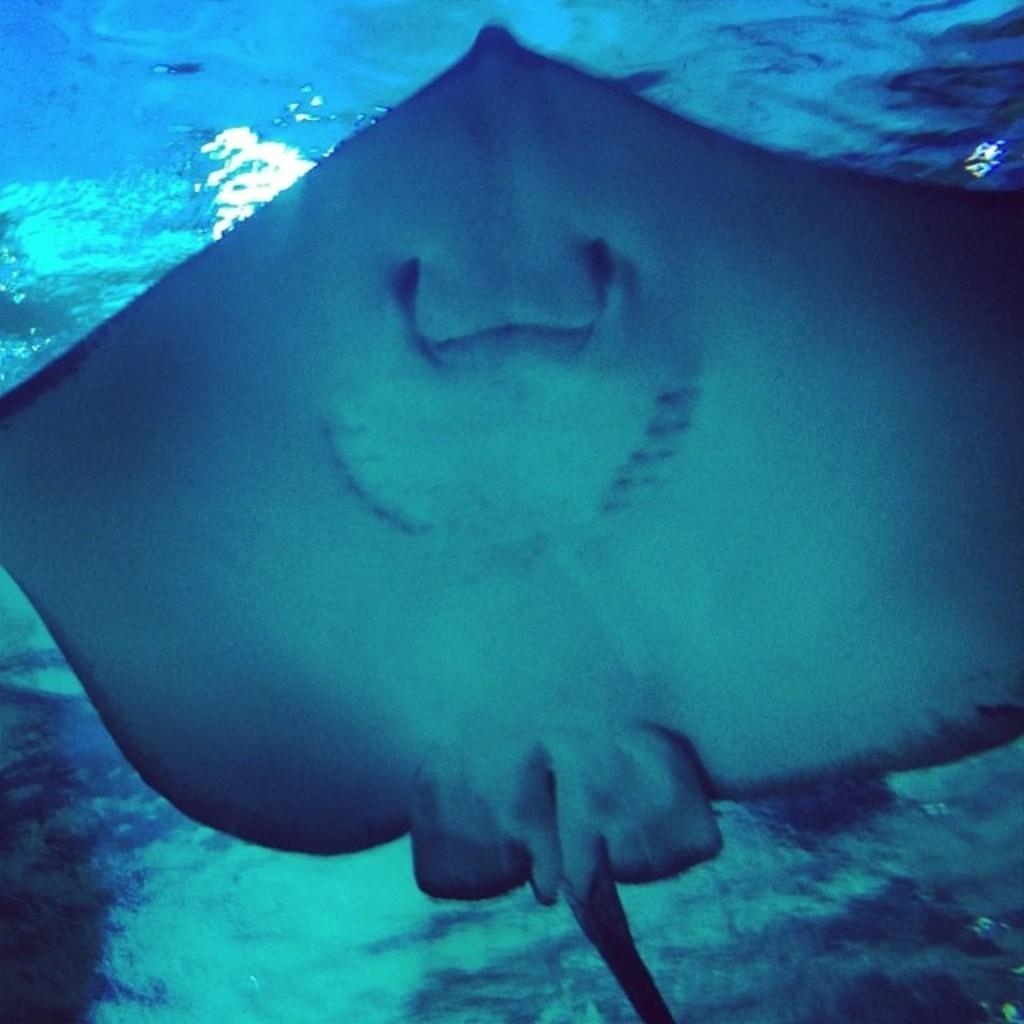What type of creature is in the center of the image? There is a water creature in the center of the image. What is the water creature doing in the image? The water creature appears to be swimming. Where is the water creature located? The water creature is in a water body. What can be seen in the background of the image? There is a water body visible in the background of the image. What type of friction can be observed between the water creature and the cart in the image? There is no cart present in the image, so there is no friction between the water creature and a cart. 